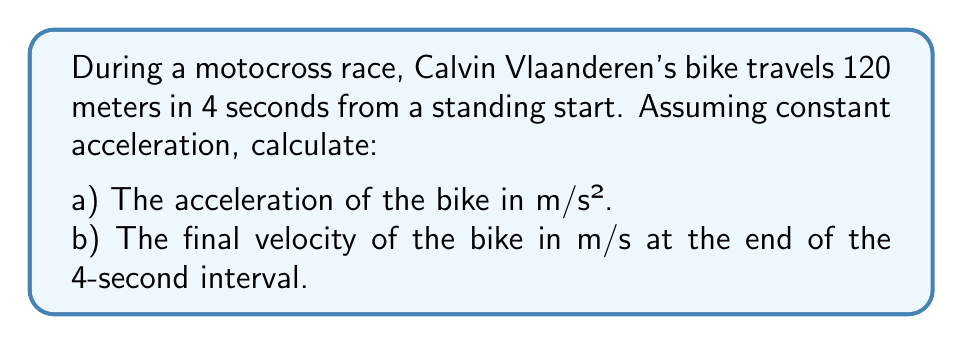Teach me how to tackle this problem. Let's solve this problem step by step using the equations of motion for constant acceleration:

1) We'll use the equation: $s = \frac{1}{2}at^2$, where
   $s$ = displacement
   $a$ = acceleration
   $t$ = time

2) We know that $s = 120$ m and $t = 4$ s. Let's substitute these values:

   $120 = \frac{1}{2}a(4)^2$

3) Simplify:
   $120 = 8a$

4) Solve for $a$:
   $a = \frac{120}{8} = 15$ m/s²

5) Now that we have the acceleration, we can find the final velocity using the equation:
   $v = at$, where $v$ is the final velocity

6) Substitute the values:
   $v = 15 \cdot 4 = 60$ m/s

Therefore, the acceleration is 15 m/s² and the final velocity is 60 m/s.
Answer: a) 15 m/s²
b) 60 m/s 